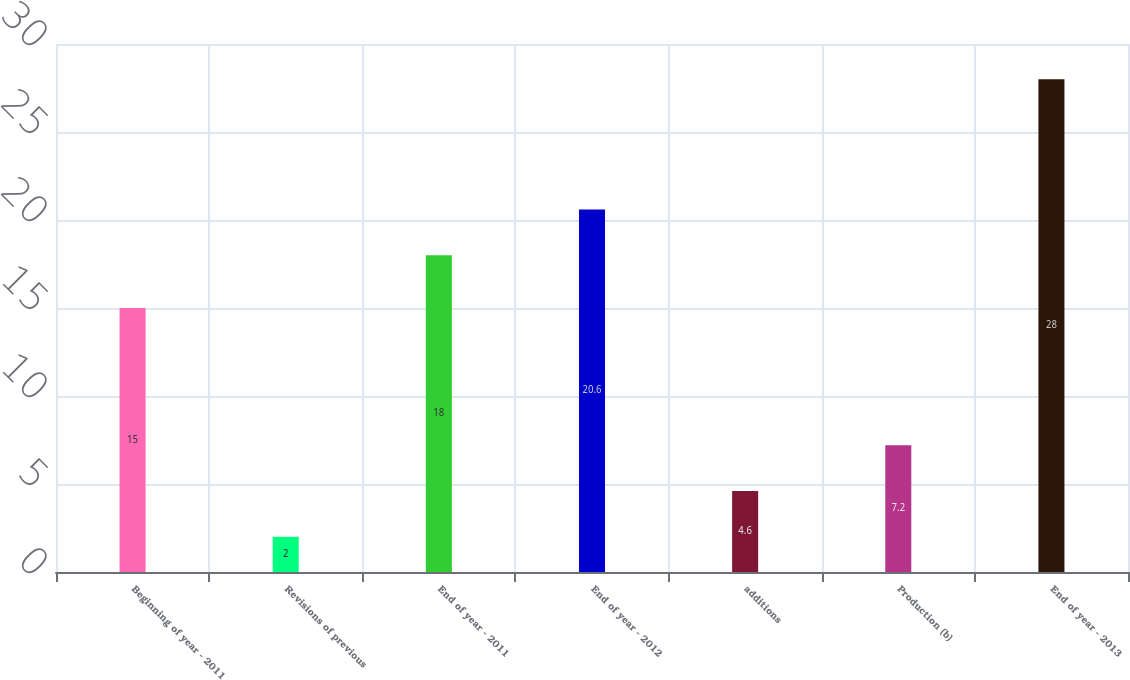Convert chart. <chart><loc_0><loc_0><loc_500><loc_500><bar_chart><fcel>Beginning of year - 2011<fcel>Revisions of previous<fcel>End of year - 2011<fcel>End of year - 2012<fcel>additions<fcel>Production (b)<fcel>End of year - 2013<nl><fcel>15<fcel>2<fcel>18<fcel>20.6<fcel>4.6<fcel>7.2<fcel>28<nl></chart> 